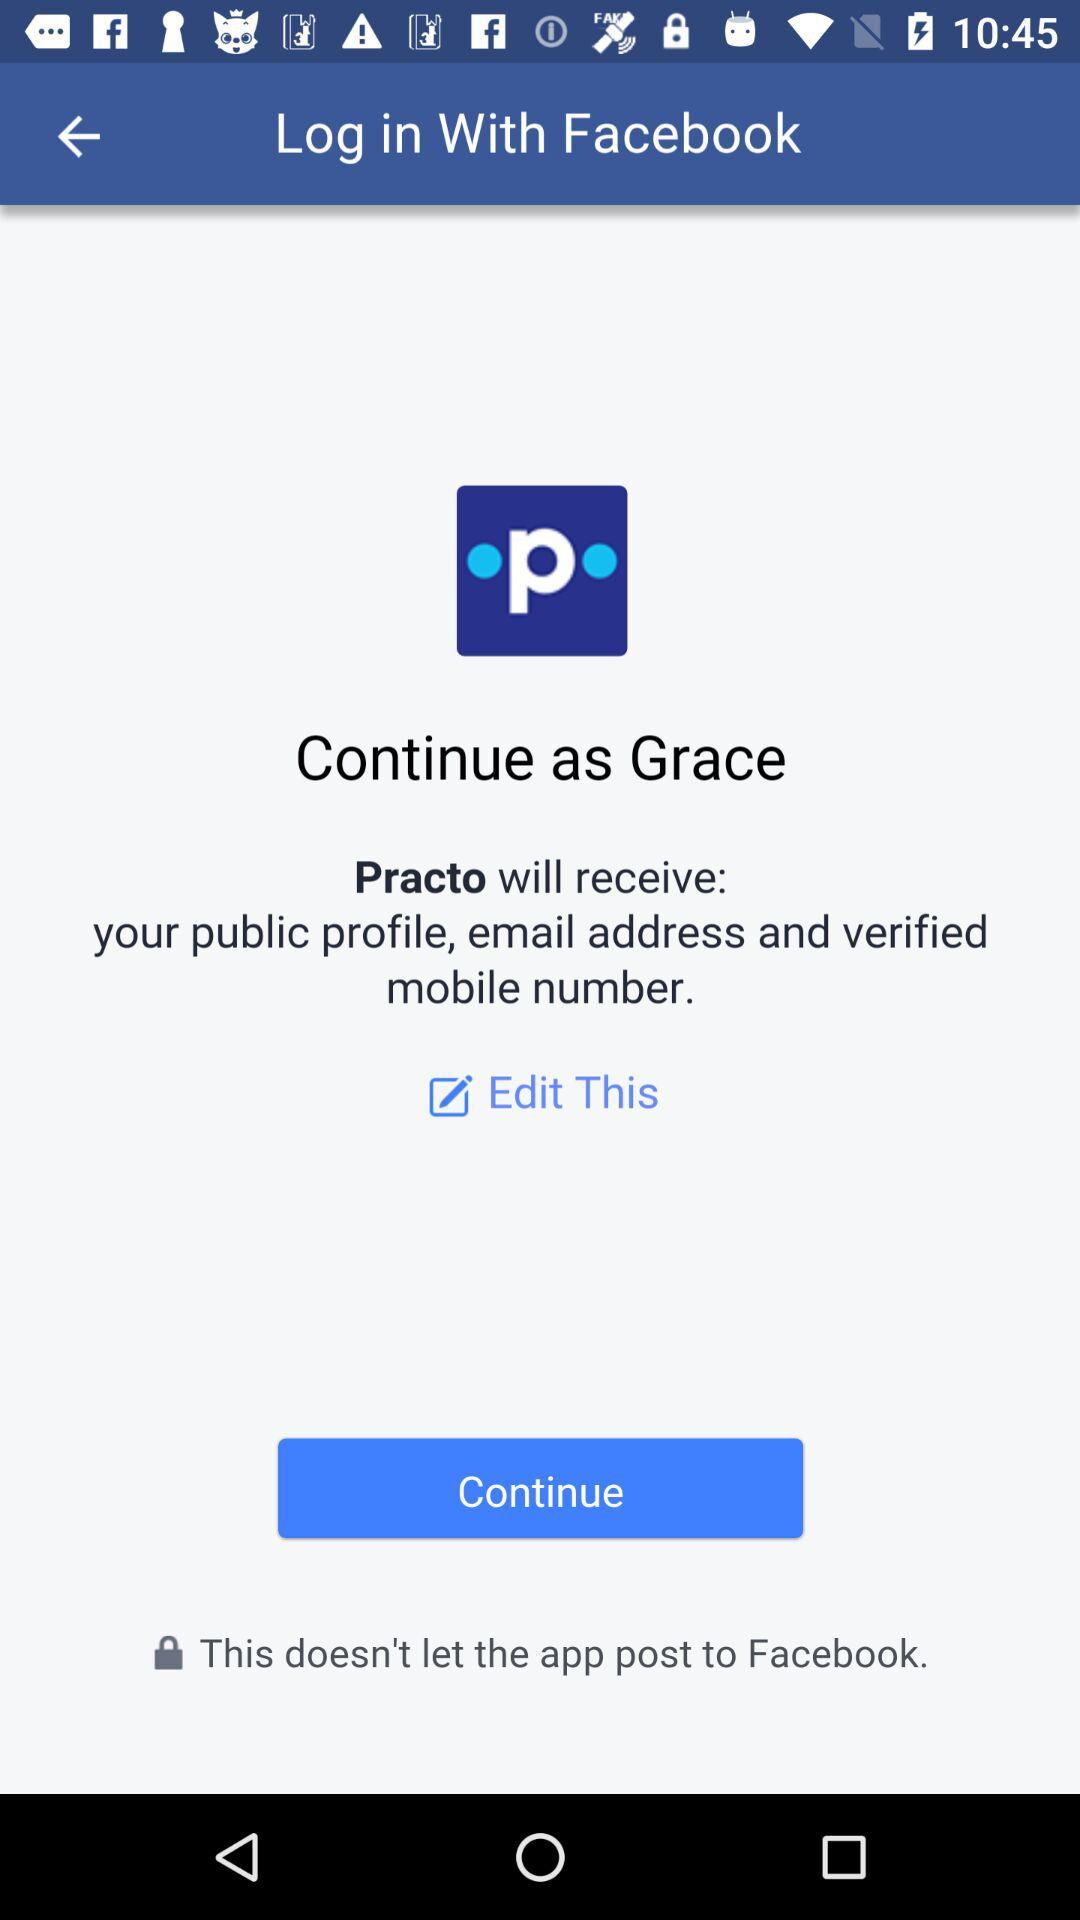What application is asking for permission? The application that is asking for permission is "Practo". 